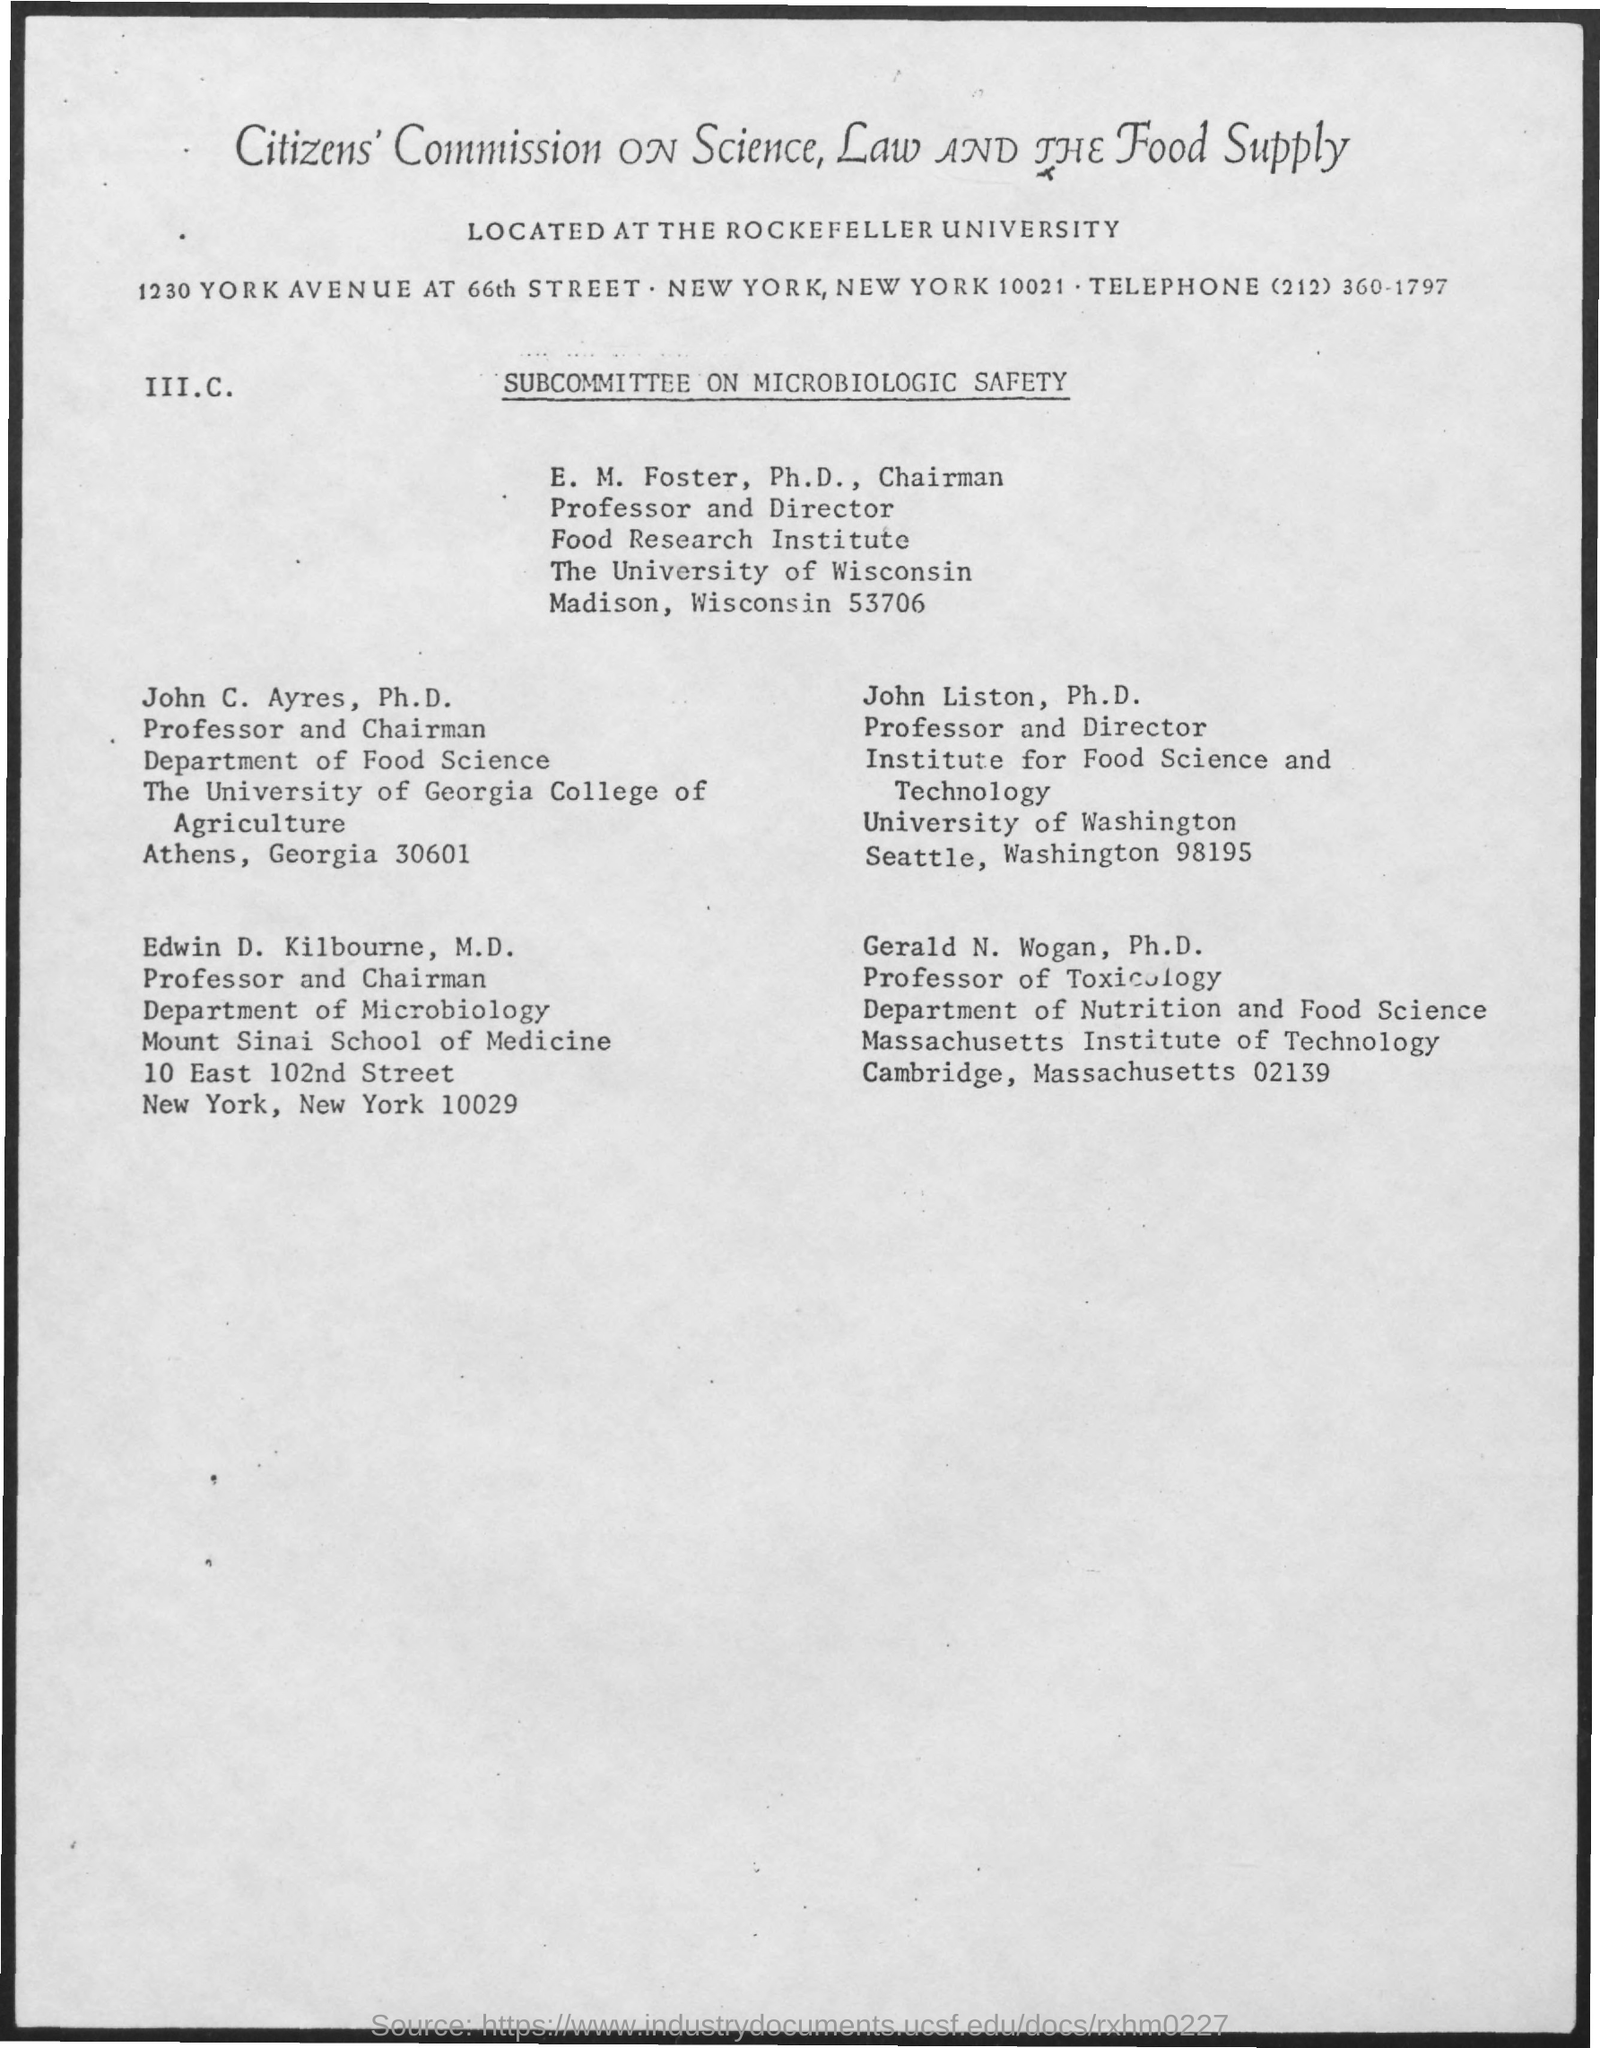Mention a couple of crucial points in this snapshot. The telephone number is (212) 360-1797. 